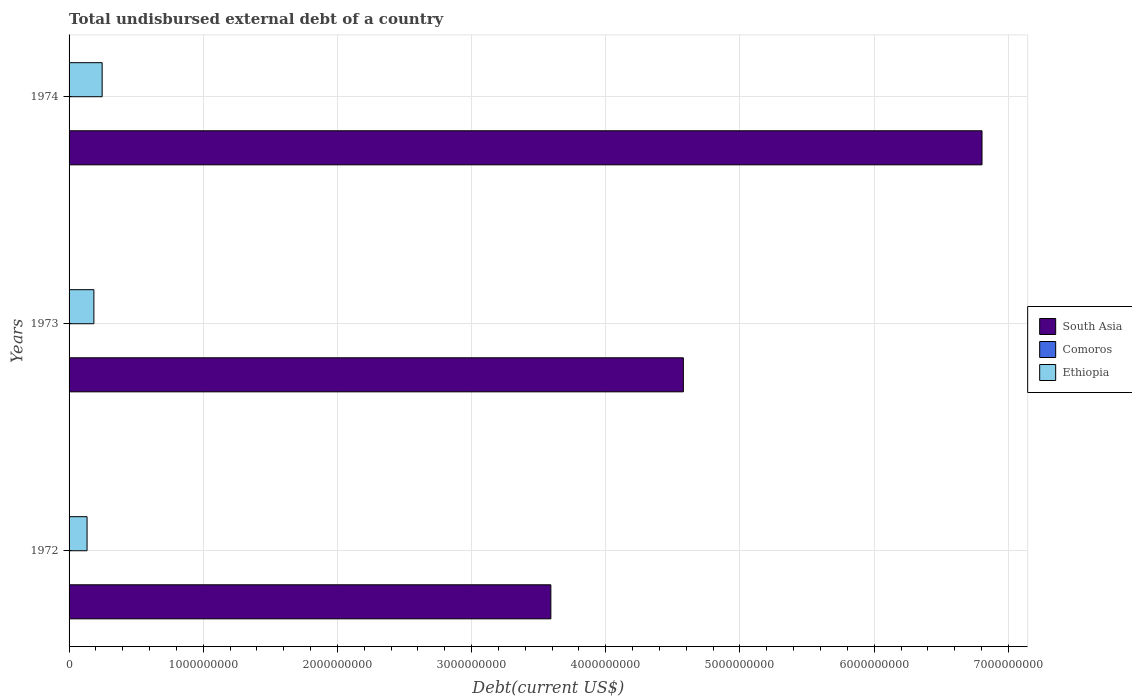How many different coloured bars are there?
Keep it short and to the point. 3. How many groups of bars are there?
Your answer should be compact. 3. Are the number of bars per tick equal to the number of legend labels?
Make the answer very short. Yes. How many bars are there on the 1st tick from the top?
Give a very brief answer. 3. How many bars are there on the 1st tick from the bottom?
Provide a short and direct response. 3. In how many cases, is the number of bars for a given year not equal to the number of legend labels?
Provide a short and direct response. 0. What is the total undisbursed external debt in South Asia in 1973?
Offer a terse response. 4.58e+09. Across all years, what is the maximum total undisbursed external debt in South Asia?
Offer a terse response. 6.80e+09. Across all years, what is the minimum total undisbursed external debt in South Asia?
Offer a terse response. 3.59e+09. In which year was the total undisbursed external debt in South Asia maximum?
Ensure brevity in your answer.  1974. In which year was the total undisbursed external debt in Ethiopia minimum?
Offer a terse response. 1972. What is the total total undisbursed external debt in South Asia in the graph?
Provide a short and direct response. 1.50e+1. What is the difference between the total undisbursed external debt in South Asia in 1973 and that in 1974?
Give a very brief answer. -2.23e+09. What is the difference between the total undisbursed external debt in South Asia in 1972 and the total undisbursed external debt in Ethiopia in 1974?
Your response must be concise. 3.34e+09. What is the average total undisbursed external debt in Ethiopia per year?
Ensure brevity in your answer.  1.89e+08. In the year 1973, what is the difference between the total undisbursed external debt in Ethiopia and total undisbursed external debt in South Asia?
Keep it short and to the point. -4.39e+09. What is the ratio of the total undisbursed external debt in Comoros in 1972 to that in 1973?
Provide a succinct answer. 0.14. Is the total undisbursed external debt in South Asia in 1972 less than that in 1974?
Your answer should be compact. Yes. Is the difference between the total undisbursed external debt in Ethiopia in 1972 and 1973 greater than the difference between the total undisbursed external debt in South Asia in 1972 and 1973?
Keep it short and to the point. Yes. What is the difference between the highest and the second highest total undisbursed external debt in South Asia?
Offer a terse response. 2.23e+09. What is the difference between the highest and the lowest total undisbursed external debt in Ethiopia?
Your response must be concise. 1.12e+08. What does the 1st bar from the top in 1974 represents?
Keep it short and to the point. Ethiopia. What does the 2nd bar from the bottom in 1973 represents?
Provide a short and direct response. Comoros. How many bars are there?
Your answer should be very brief. 9. How many years are there in the graph?
Your answer should be compact. 3. Where does the legend appear in the graph?
Provide a succinct answer. Center right. How many legend labels are there?
Ensure brevity in your answer.  3. What is the title of the graph?
Offer a very short reply. Total undisbursed external debt of a country. Does "Bhutan" appear as one of the legend labels in the graph?
Offer a terse response. No. What is the label or title of the X-axis?
Offer a very short reply. Debt(current US$). What is the label or title of the Y-axis?
Keep it short and to the point. Years. What is the Debt(current US$) in South Asia in 1972?
Offer a terse response. 3.59e+09. What is the Debt(current US$) of Comoros in 1972?
Offer a terse response. 5.90e+04. What is the Debt(current US$) of Ethiopia in 1972?
Offer a very short reply. 1.34e+08. What is the Debt(current US$) of South Asia in 1973?
Your response must be concise. 4.58e+09. What is the Debt(current US$) of Comoros in 1973?
Your answer should be compact. 4.33e+05. What is the Debt(current US$) in Ethiopia in 1973?
Offer a very short reply. 1.85e+08. What is the Debt(current US$) of South Asia in 1974?
Give a very brief answer. 6.80e+09. What is the Debt(current US$) in Comoros in 1974?
Your response must be concise. 4.65e+05. What is the Debt(current US$) of Ethiopia in 1974?
Provide a succinct answer. 2.47e+08. Across all years, what is the maximum Debt(current US$) in South Asia?
Offer a very short reply. 6.80e+09. Across all years, what is the maximum Debt(current US$) of Comoros?
Your response must be concise. 4.65e+05. Across all years, what is the maximum Debt(current US$) in Ethiopia?
Ensure brevity in your answer.  2.47e+08. Across all years, what is the minimum Debt(current US$) of South Asia?
Provide a succinct answer. 3.59e+09. Across all years, what is the minimum Debt(current US$) of Comoros?
Make the answer very short. 5.90e+04. Across all years, what is the minimum Debt(current US$) of Ethiopia?
Your answer should be compact. 1.34e+08. What is the total Debt(current US$) of South Asia in the graph?
Offer a very short reply. 1.50e+1. What is the total Debt(current US$) in Comoros in the graph?
Ensure brevity in your answer.  9.57e+05. What is the total Debt(current US$) in Ethiopia in the graph?
Offer a very short reply. 5.66e+08. What is the difference between the Debt(current US$) in South Asia in 1972 and that in 1973?
Offer a terse response. -9.87e+08. What is the difference between the Debt(current US$) of Comoros in 1972 and that in 1973?
Your response must be concise. -3.74e+05. What is the difference between the Debt(current US$) of Ethiopia in 1972 and that in 1973?
Make the answer very short. -5.09e+07. What is the difference between the Debt(current US$) of South Asia in 1972 and that in 1974?
Your response must be concise. -3.21e+09. What is the difference between the Debt(current US$) in Comoros in 1972 and that in 1974?
Offer a terse response. -4.06e+05. What is the difference between the Debt(current US$) in Ethiopia in 1972 and that in 1974?
Offer a terse response. -1.12e+08. What is the difference between the Debt(current US$) of South Asia in 1973 and that in 1974?
Give a very brief answer. -2.23e+09. What is the difference between the Debt(current US$) in Comoros in 1973 and that in 1974?
Make the answer very short. -3.20e+04. What is the difference between the Debt(current US$) in Ethiopia in 1973 and that in 1974?
Provide a succinct answer. -6.16e+07. What is the difference between the Debt(current US$) in South Asia in 1972 and the Debt(current US$) in Comoros in 1973?
Your response must be concise. 3.59e+09. What is the difference between the Debt(current US$) of South Asia in 1972 and the Debt(current US$) of Ethiopia in 1973?
Your answer should be compact. 3.41e+09. What is the difference between the Debt(current US$) in Comoros in 1972 and the Debt(current US$) in Ethiopia in 1973?
Offer a terse response. -1.85e+08. What is the difference between the Debt(current US$) of South Asia in 1972 and the Debt(current US$) of Comoros in 1974?
Keep it short and to the point. 3.59e+09. What is the difference between the Debt(current US$) of South Asia in 1972 and the Debt(current US$) of Ethiopia in 1974?
Give a very brief answer. 3.34e+09. What is the difference between the Debt(current US$) of Comoros in 1972 and the Debt(current US$) of Ethiopia in 1974?
Provide a short and direct response. -2.47e+08. What is the difference between the Debt(current US$) in South Asia in 1973 and the Debt(current US$) in Comoros in 1974?
Make the answer very short. 4.58e+09. What is the difference between the Debt(current US$) of South Asia in 1973 and the Debt(current US$) of Ethiopia in 1974?
Your answer should be compact. 4.33e+09. What is the difference between the Debt(current US$) of Comoros in 1973 and the Debt(current US$) of Ethiopia in 1974?
Offer a terse response. -2.46e+08. What is the average Debt(current US$) of South Asia per year?
Provide a succinct answer. 4.99e+09. What is the average Debt(current US$) of Comoros per year?
Keep it short and to the point. 3.19e+05. What is the average Debt(current US$) in Ethiopia per year?
Offer a terse response. 1.89e+08. In the year 1972, what is the difference between the Debt(current US$) of South Asia and Debt(current US$) of Comoros?
Keep it short and to the point. 3.59e+09. In the year 1972, what is the difference between the Debt(current US$) in South Asia and Debt(current US$) in Ethiopia?
Offer a very short reply. 3.46e+09. In the year 1972, what is the difference between the Debt(current US$) of Comoros and Debt(current US$) of Ethiopia?
Your answer should be very brief. -1.34e+08. In the year 1973, what is the difference between the Debt(current US$) in South Asia and Debt(current US$) in Comoros?
Your answer should be very brief. 4.58e+09. In the year 1973, what is the difference between the Debt(current US$) of South Asia and Debt(current US$) of Ethiopia?
Ensure brevity in your answer.  4.39e+09. In the year 1973, what is the difference between the Debt(current US$) of Comoros and Debt(current US$) of Ethiopia?
Keep it short and to the point. -1.85e+08. In the year 1974, what is the difference between the Debt(current US$) of South Asia and Debt(current US$) of Comoros?
Give a very brief answer. 6.80e+09. In the year 1974, what is the difference between the Debt(current US$) of South Asia and Debt(current US$) of Ethiopia?
Keep it short and to the point. 6.56e+09. In the year 1974, what is the difference between the Debt(current US$) in Comoros and Debt(current US$) in Ethiopia?
Offer a very short reply. -2.46e+08. What is the ratio of the Debt(current US$) of South Asia in 1972 to that in 1973?
Provide a succinct answer. 0.78. What is the ratio of the Debt(current US$) in Comoros in 1972 to that in 1973?
Your answer should be very brief. 0.14. What is the ratio of the Debt(current US$) in Ethiopia in 1972 to that in 1973?
Provide a succinct answer. 0.72. What is the ratio of the Debt(current US$) in South Asia in 1972 to that in 1974?
Offer a very short reply. 0.53. What is the ratio of the Debt(current US$) in Comoros in 1972 to that in 1974?
Your answer should be very brief. 0.13. What is the ratio of the Debt(current US$) of Ethiopia in 1972 to that in 1974?
Ensure brevity in your answer.  0.54. What is the ratio of the Debt(current US$) of South Asia in 1973 to that in 1974?
Offer a very short reply. 0.67. What is the ratio of the Debt(current US$) of Comoros in 1973 to that in 1974?
Offer a terse response. 0.93. What is the ratio of the Debt(current US$) in Ethiopia in 1973 to that in 1974?
Ensure brevity in your answer.  0.75. What is the difference between the highest and the second highest Debt(current US$) of South Asia?
Keep it short and to the point. 2.23e+09. What is the difference between the highest and the second highest Debt(current US$) of Comoros?
Your answer should be compact. 3.20e+04. What is the difference between the highest and the second highest Debt(current US$) of Ethiopia?
Your answer should be compact. 6.16e+07. What is the difference between the highest and the lowest Debt(current US$) in South Asia?
Offer a terse response. 3.21e+09. What is the difference between the highest and the lowest Debt(current US$) in Comoros?
Offer a terse response. 4.06e+05. What is the difference between the highest and the lowest Debt(current US$) in Ethiopia?
Make the answer very short. 1.12e+08. 